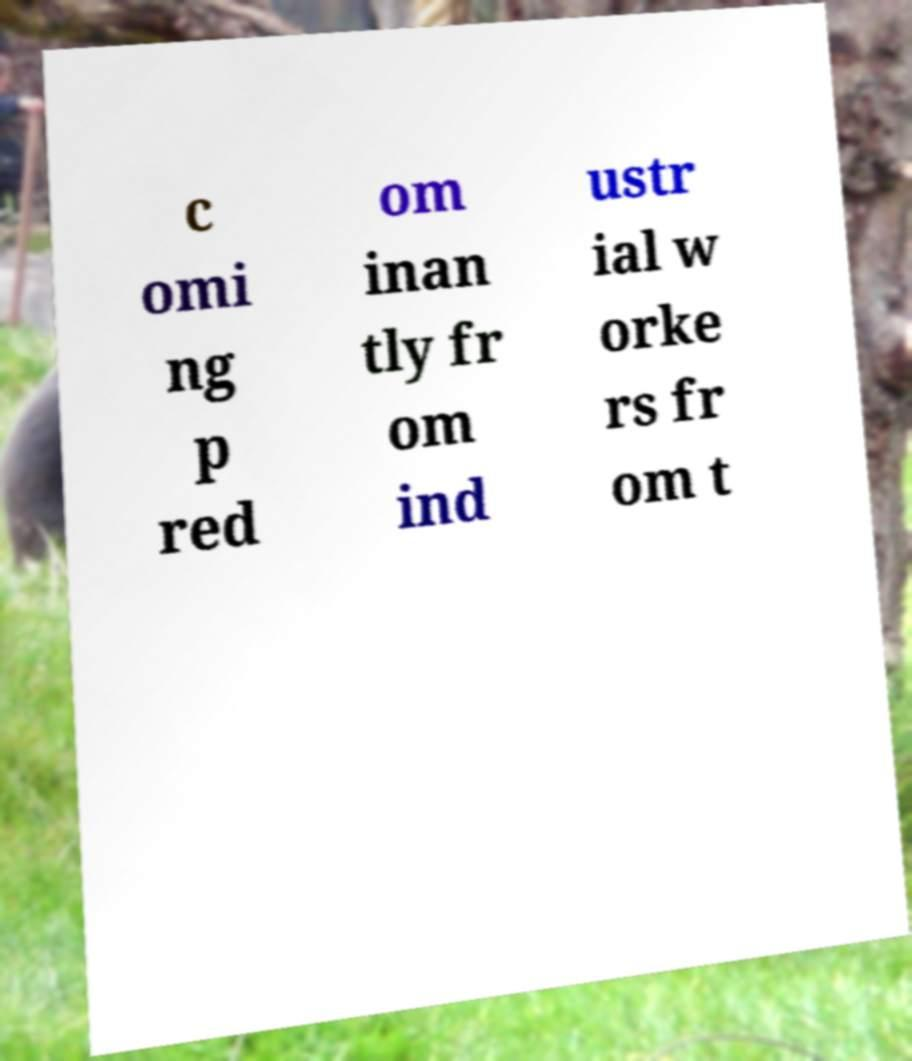What messages or text are displayed in this image? I need them in a readable, typed format. c omi ng p red om inan tly fr om ind ustr ial w orke rs fr om t 